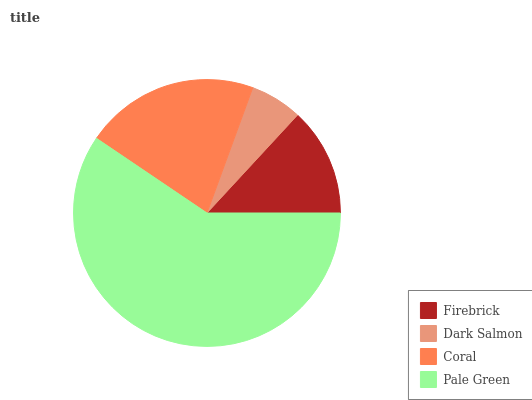Is Dark Salmon the minimum?
Answer yes or no. Yes. Is Pale Green the maximum?
Answer yes or no. Yes. Is Coral the minimum?
Answer yes or no. No. Is Coral the maximum?
Answer yes or no. No. Is Coral greater than Dark Salmon?
Answer yes or no. Yes. Is Dark Salmon less than Coral?
Answer yes or no. Yes. Is Dark Salmon greater than Coral?
Answer yes or no. No. Is Coral less than Dark Salmon?
Answer yes or no. No. Is Coral the high median?
Answer yes or no. Yes. Is Firebrick the low median?
Answer yes or no. Yes. Is Firebrick the high median?
Answer yes or no. No. Is Dark Salmon the low median?
Answer yes or no. No. 